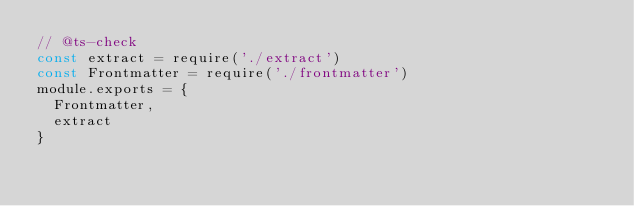Convert code to text. <code><loc_0><loc_0><loc_500><loc_500><_JavaScript_>// @ts-check
const extract = require('./extract')
const Frontmatter = require('./frontmatter')
module.exports = {
  Frontmatter,
  extract
}
</code> 